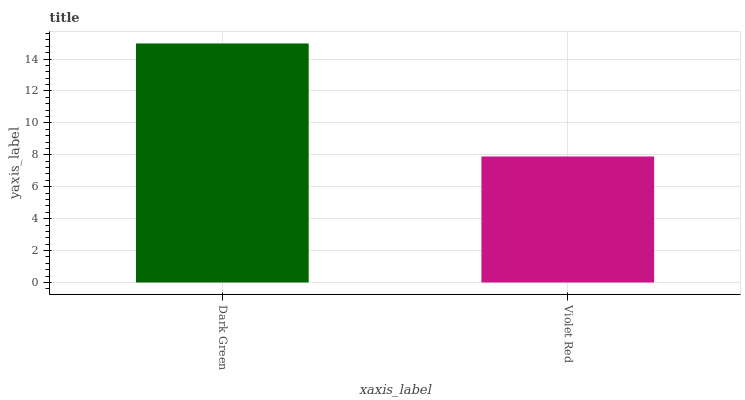Is Violet Red the minimum?
Answer yes or no. Yes. Is Dark Green the maximum?
Answer yes or no. Yes. Is Violet Red the maximum?
Answer yes or no. No. Is Dark Green greater than Violet Red?
Answer yes or no. Yes. Is Violet Red less than Dark Green?
Answer yes or no. Yes. Is Violet Red greater than Dark Green?
Answer yes or no. No. Is Dark Green less than Violet Red?
Answer yes or no. No. Is Dark Green the high median?
Answer yes or no. Yes. Is Violet Red the low median?
Answer yes or no. Yes. Is Violet Red the high median?
Answer yes or no. No. Is Dark Green the low median?
Answer yes or no. No. 